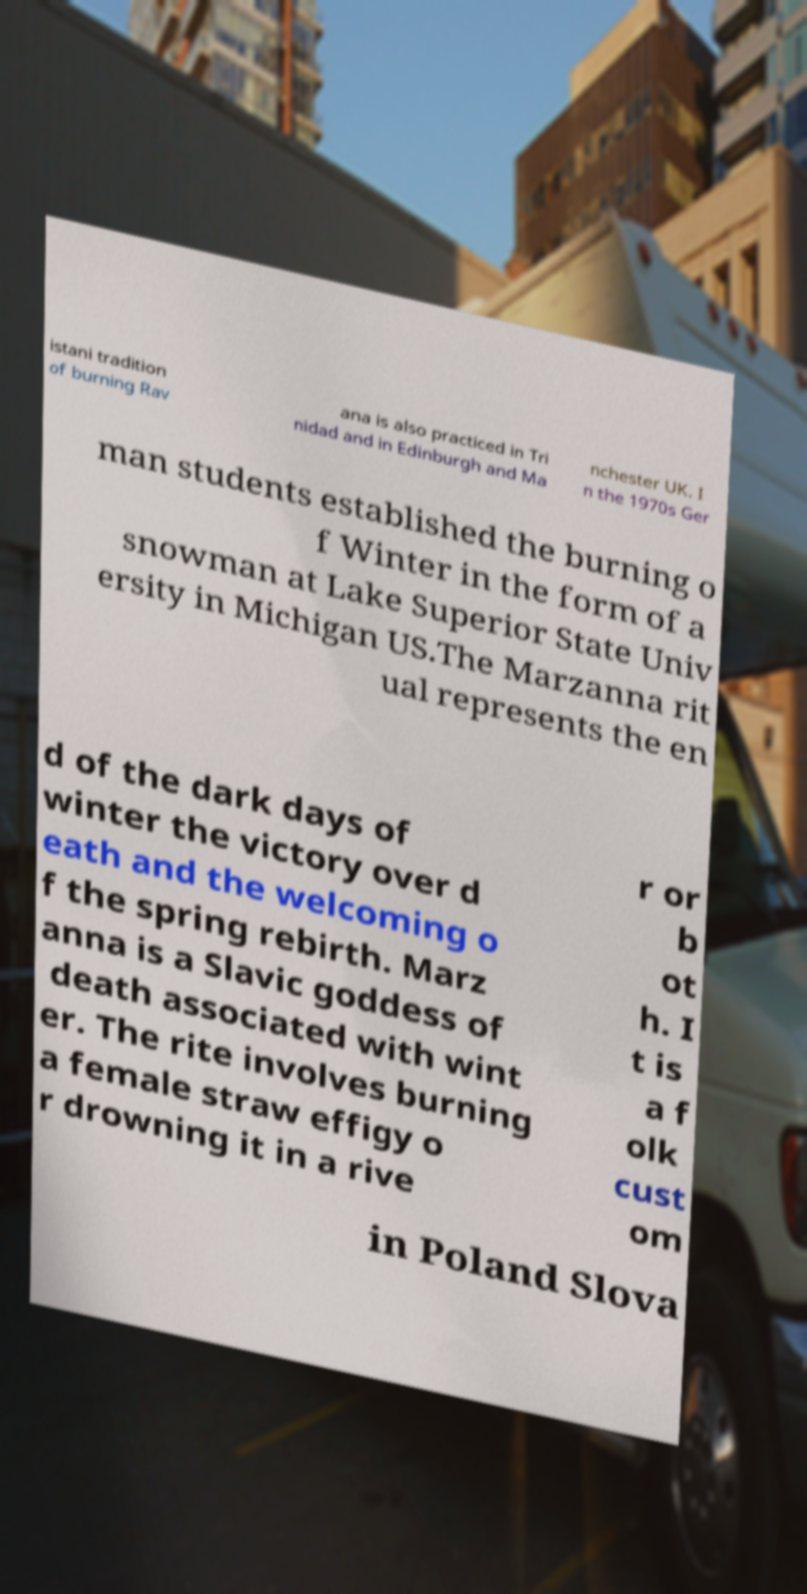Could you assist in decoding the text presented in this image and type it out clearly? istani tradition of burning Rav ana is also practiced in Tri nidad and in Edinburgh and Ma nchester UK. I n the 1970s Ger man students established the burning o f Winter in the form of a snowman at Lake Superior State Univ ersity in Michigan US.The Marzanna rit ual represents the en d of the dark days of winter the victory over d eath and the welcoming o f the spring rebirth. Marz anna is a Slavic goddess of death associated with wint er. The rite involves burning a female straw effigy o r drowning it in a rive r or b ot h. I t is a f olk cust om in Poland Slova 